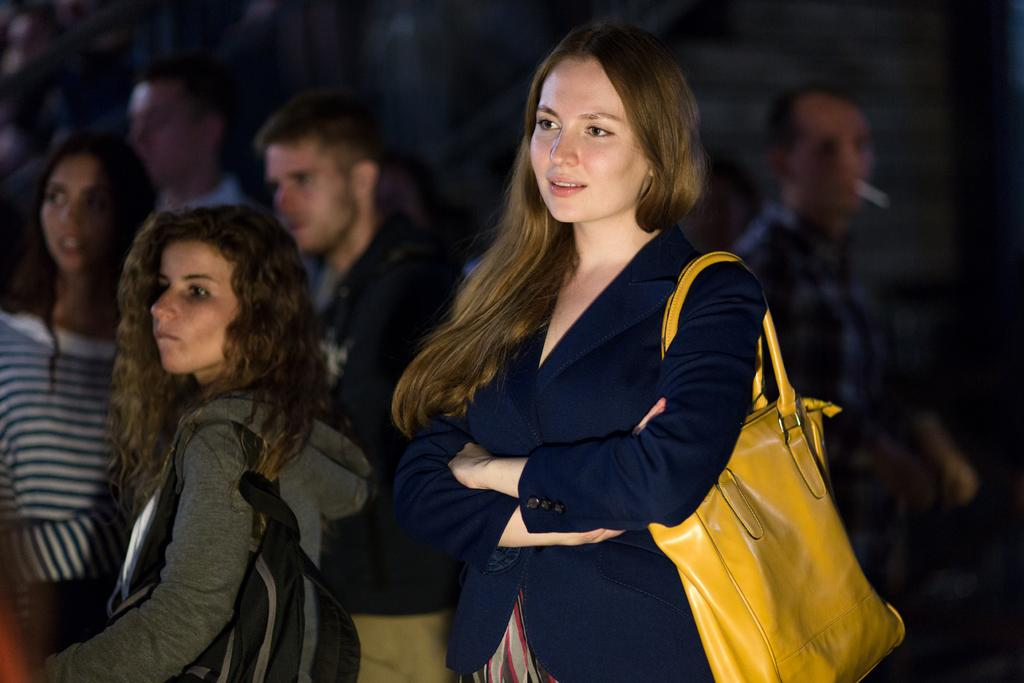What can be seen in the image? There is a group of people in the image. Can you describe any specific person in the image? A lady is highlighted in the image. What is the lady wearing? The lady is wearing a blue color jacket. What accessory is the lady carrying? The lady is carrying a yellow handbag. What type of sheet is the lady using to cover the books in the image? There is no sheet or books present in the image; it only features a group of people with a highlighted lady wearing a blue jacket and carrying a yellow handbag. 